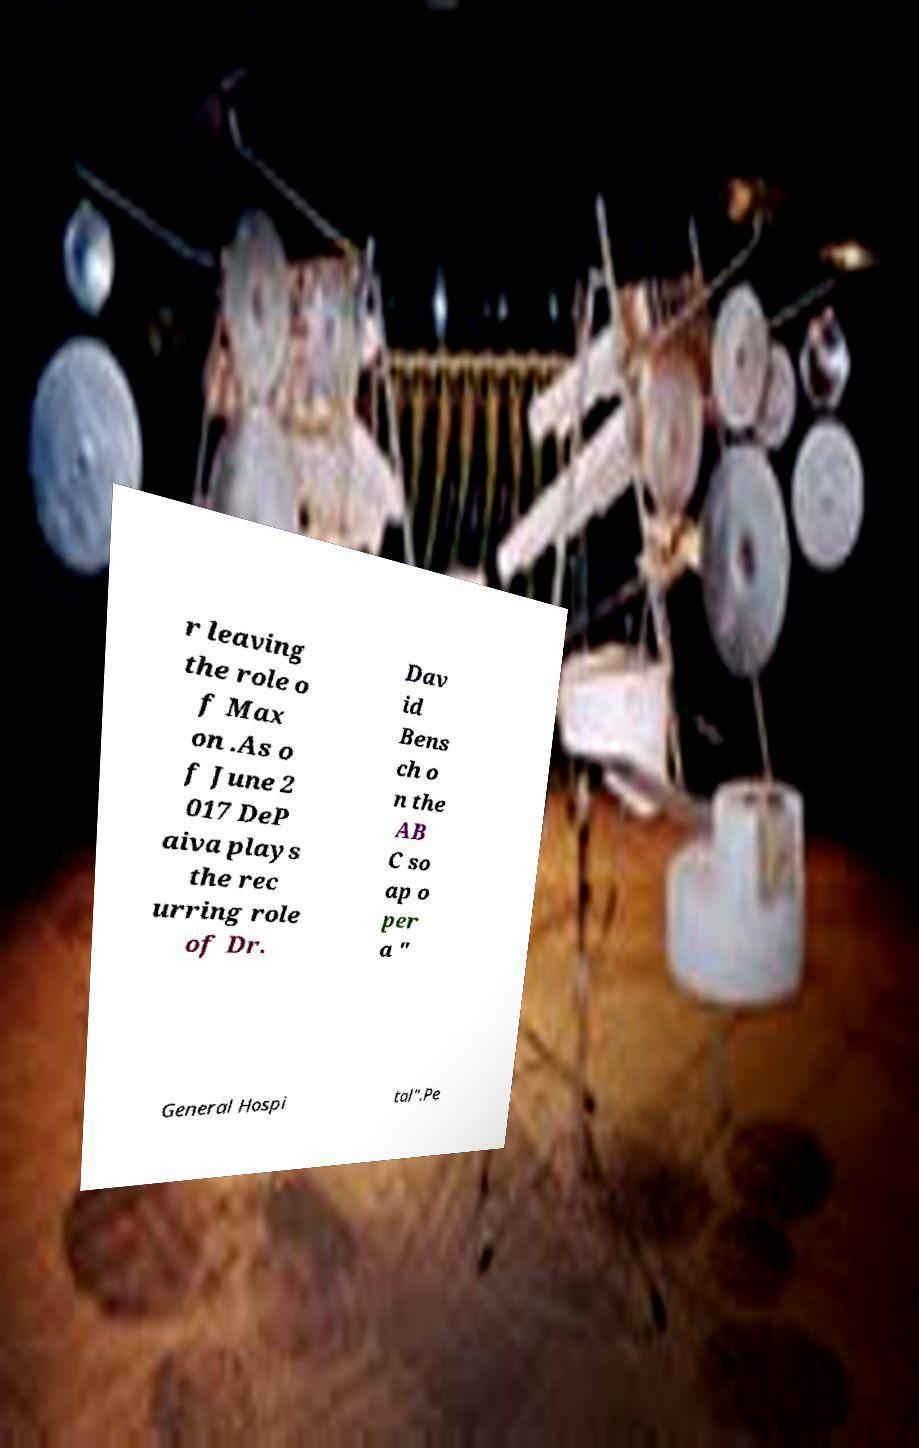For documentation purposes, I need the text within this image transcribed. Could you provide that? r leaving the role o f Max on .As o f June 2 017 DeP aiva plays the rec urring role of Dr. Dav id Bens ch o n the AB C so ap o per a " General Hospi tal".Pe 